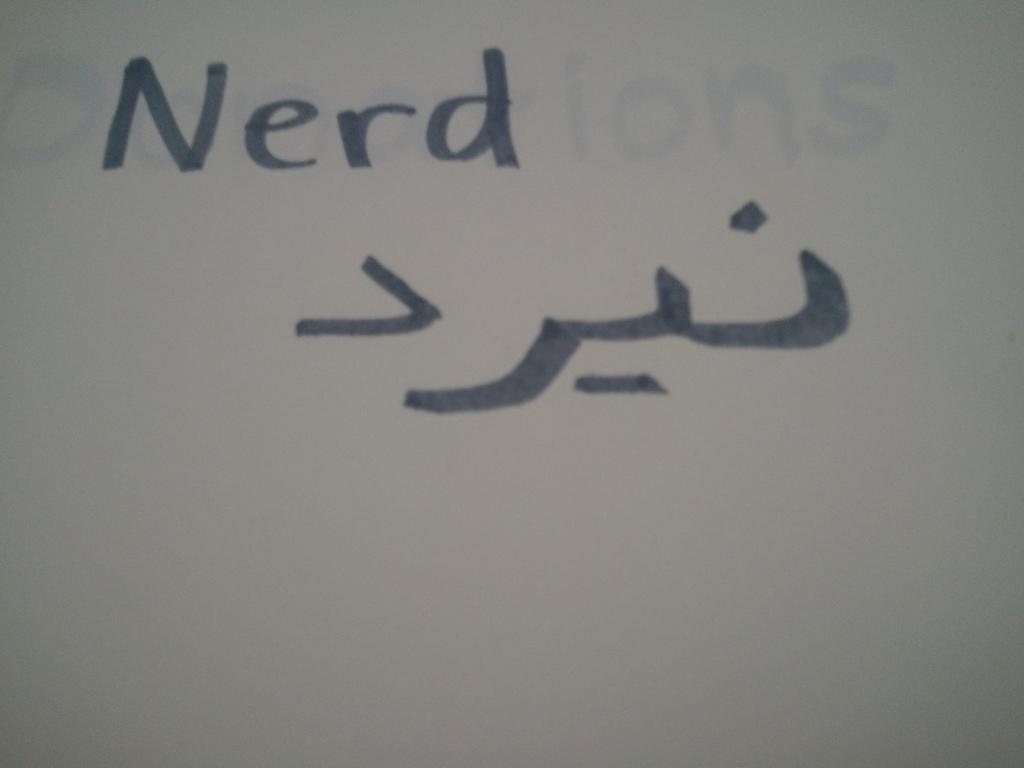<image>
Present a compact description of the photo's key features. Nerd written out in English as well as another language. 